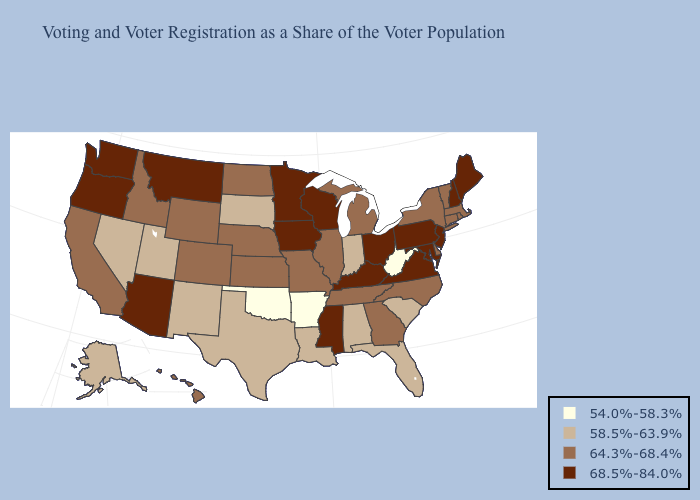Does Maryland have the highest value in the USA?
Short answer required. Yes. What is the highest value in the USA?
Be succinct. 68.5%-84.0%. Name the states that have a value in the range 64.3%-68.4%?
Short answer required. California, Colorado, Connecticut, Delaware, Georgia, Hawaii, Idaho, Illinois, Kansas, Massachusetts, Michigan, Missouri, Nebraska, New York, North Carolina, North Dakota, Rhode Island, Tennessee, Vermont, Wyoming. Does Arizona have a lower value than Georgia?
Short answer required. No. What is the lowest value in states that border Maine?
Short answer required. 68.5%-84.0%. What is the value of Wyoming?
Write a very short answer. 64.3%-68.4%. What is the value of West Virginia?
Be succinct. 54.0%-58.3%. Among the states that border North Dakota , does South Dakota have the lowest value?
Short answer required. Yes. Among the states that border Vermont , which have the lowest value?
Be succinct. Massachusetts, New York. Among the states that border Georgia , which have the lowest value?
Write a very short answer. Alabama, Florida, South Carolina. Name the states that have a value in the range 58.5%-63.9%?
Give a very brief answer. Alabama, Alaska, Florida, Indiana, Louisiana, Nevada, New Mexico, South Carolina, South Dakota, Texas, Utah. Name the states that have a value in the range 58.5%-63.9%?
Give a very brief answer. Alabama, Alaska, Florida, Indiana, Louisiana, Nevada, New Mexico, South Carolina, South Dakota, Texas, Utah. What is the value of Nebraska?
Be succinct. 64.3%-68.4%. What is the highest value in the MidWest ?
Keep it brief. 68.5%-84.0%. Does Hawaii have a lower value than New Jersey?
Give a very brief answer. Yes. 